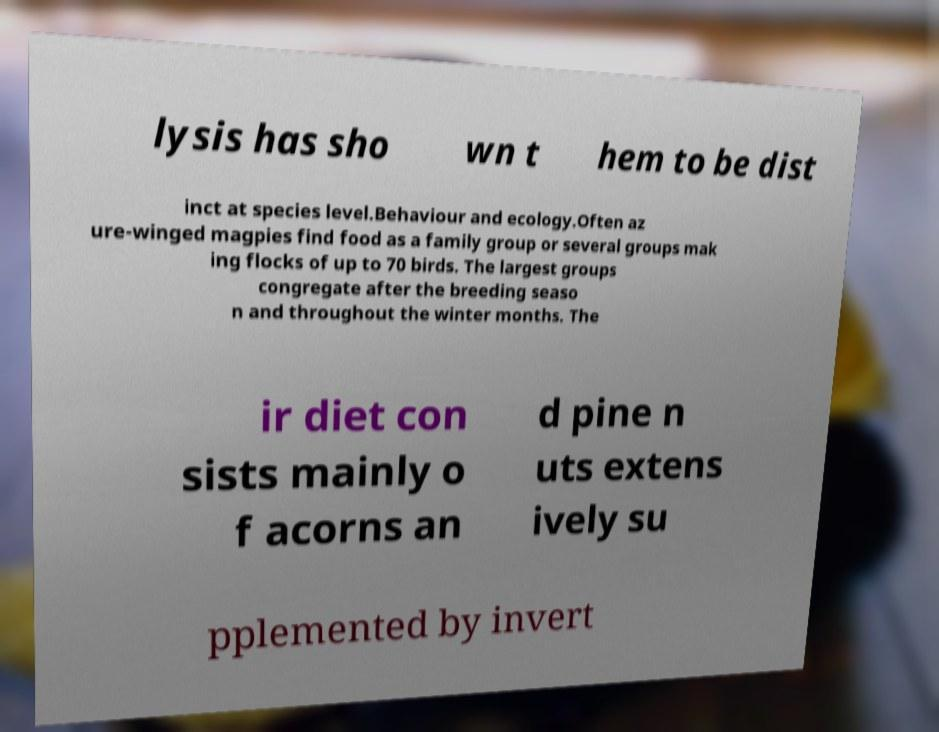Could you assist in decoding the text presented in this image and type it out clearly? lysis has sho wn t hem to be dist inct at species level.Behaviour and ecology.Often az ure-winged magpies find food as a family group or several groups mak ing flocks of up to 70 birds. The largest groups congregate after the breeding seaso n and throughout the winter months. The ir diet con sists mainly o f acorns an d pine n uts extens ively su pplemented by invert 